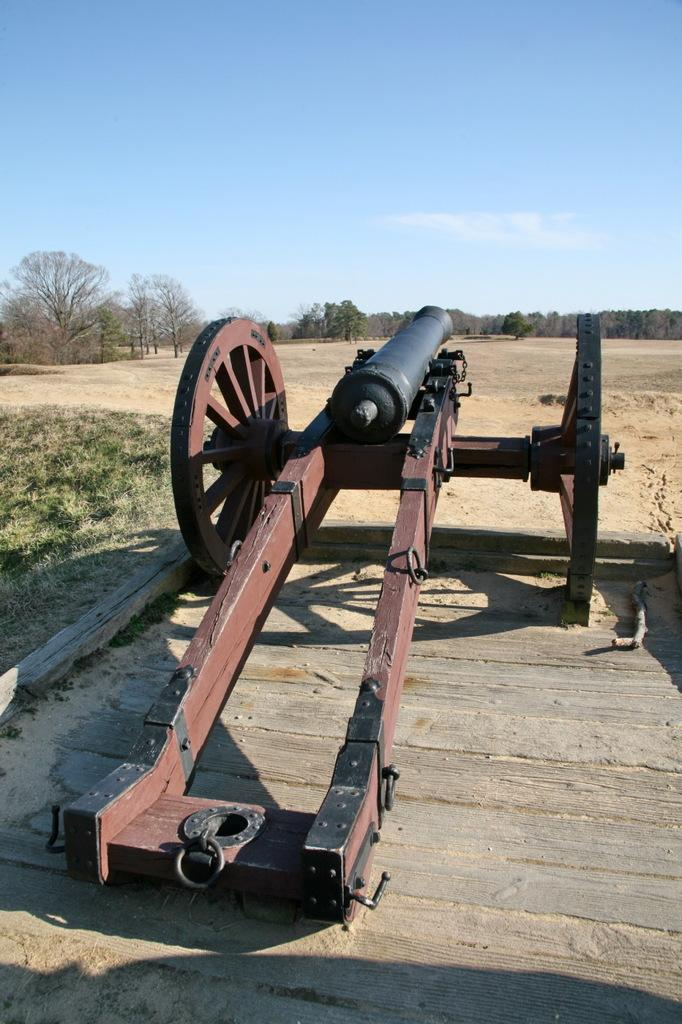What is the main object in the image? There is a cannon in the image. Where is the cannon located? The cannon is on a surface. What can be seen behind the cannon? There is a group of trees behind the cannon. What is visible at the top of the image? The sky is visible at the top of the image and is clear. Can you tell me how many goldfish are swimming in the cannon in the image? There are no goldfish present in the image, and the cannon is not a body of water where goldfish could swim. 